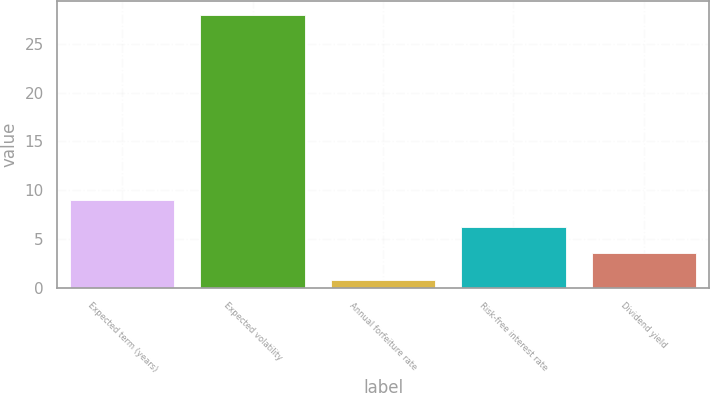<chart> <loc_0><loc_0><loc_500><loc_500><bar_chart><fcel>Expected term (years)<fcel>Expected volatility<fcel>Annual forfeiture rate<fcel>Risk-free interest rate<fcel>Dividend yield<nl><fcel>8.96<fcel>28<fcel>0.8<fcel>6.24<fcel>3.52<nl></chart> 